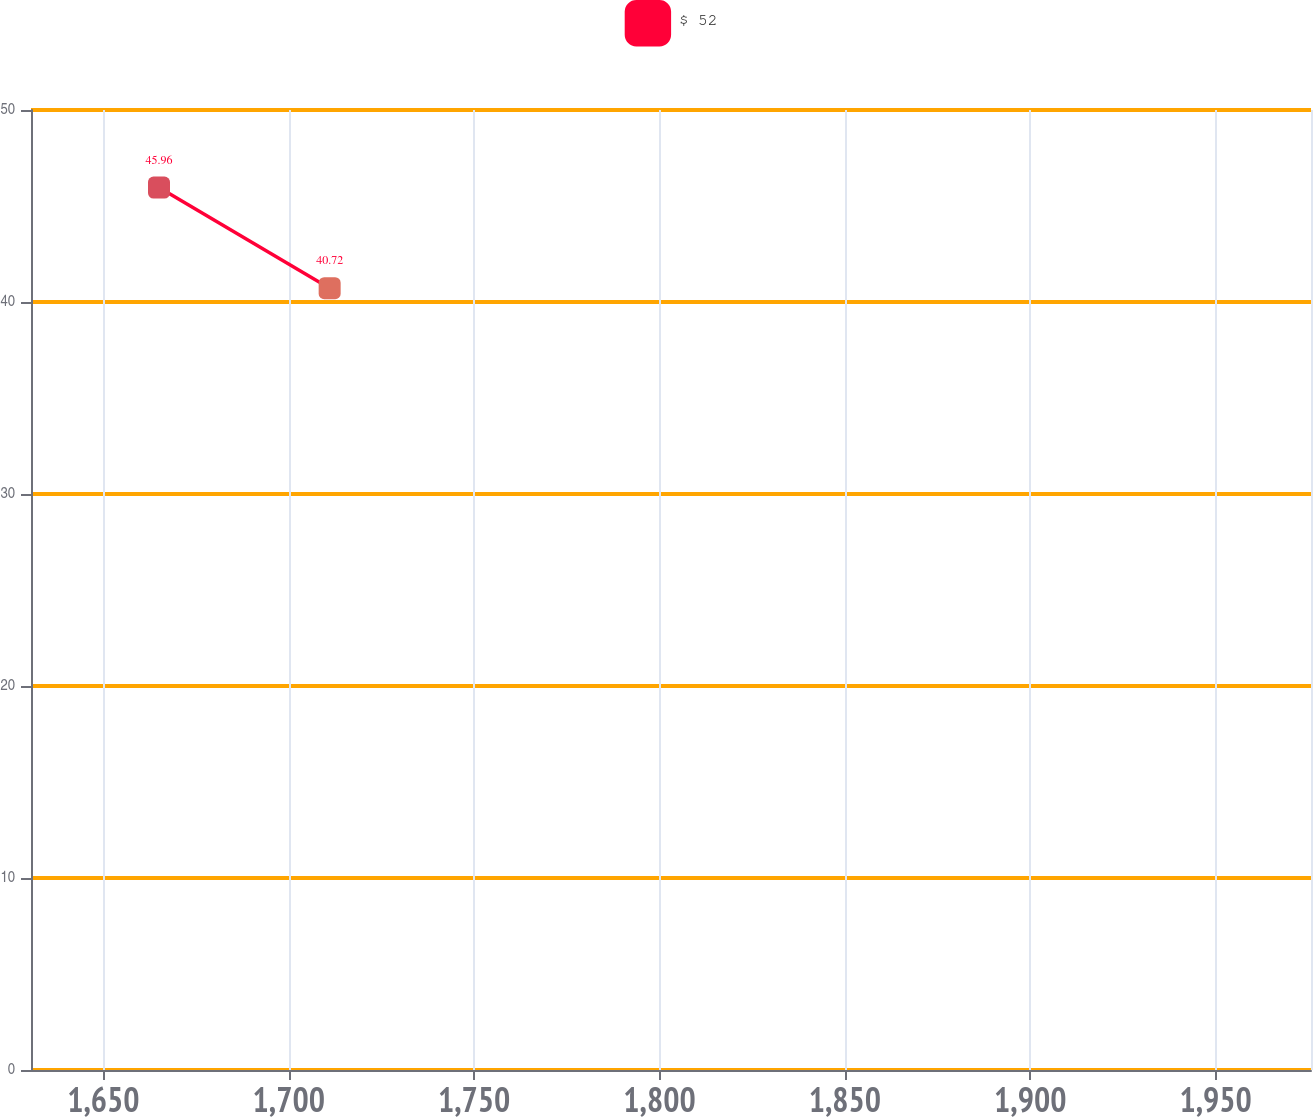<chart> <loc_0><loc_0><loc_500><loc_500><line_chart><ecel><fcel>$ 52<nl><fcel>1665<fcel>45.96<nl><fcel>1711.03<fcel>40.72<nl><fcel>1976.15<fcel>30.33<nl><fcel>2010.24<fcel>7.49<nl></chart> 